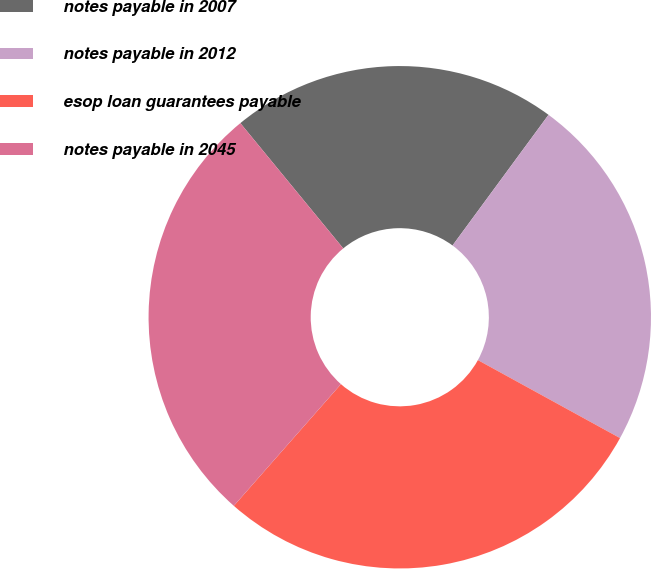Convert chart to OTSL. <chart><loc_0><loc_0><loc_500><loc_500><pie_chart><fcel>notes payable in 2007<fcel>notes payable in 2012<fcel>esop loan guarantees payable<fcel>notes payable in 2045<nl><fcel>21.03%<fcel>22.9%<fcel>28.5%<fcel>27.57%<nl></chart> 